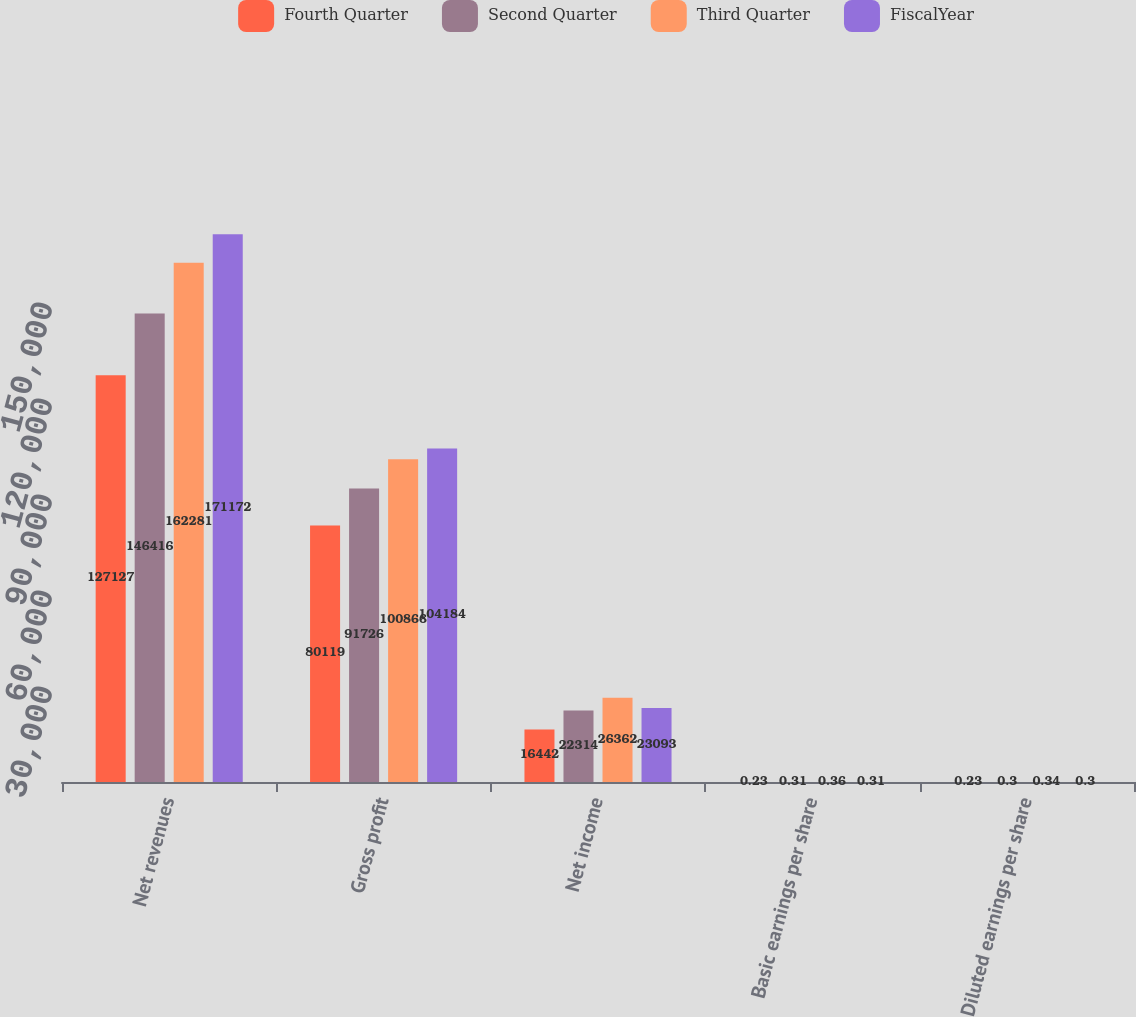Convert chart to OTSL. <chart><loc_0><loc_0><loc_500><loc_500><stacked_bar_chart><ecel><fcel>Net revenues<fcel>Gross profit<fcel>Net income<fcel>Basic earnings per share<fcel>Diluted earnings per share<nl><fcel>Fourth Quarter<fcel>127127<fcel>80119<fcel>16442<fcel>0.23<fcel>0.23<nl><fcel>Second Quarter<fcel>146416<fcel>91726<fcel>22314<fcel>0.31<fcel>0.3<nl><fcel>Third Quarter<fcel>162281<fcel>100866<fcel>26362<fcel>0.36<fcel>0.34<nl><fcel>FiscalYear<fcel>171172<fcel>104184<fcel>23093<fcel>0.31<fcel>0.3<nl></chart> 